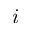Convert formula to latex. <formula><loc_0><loc_0><loc_500><loc_500>i</formula> 